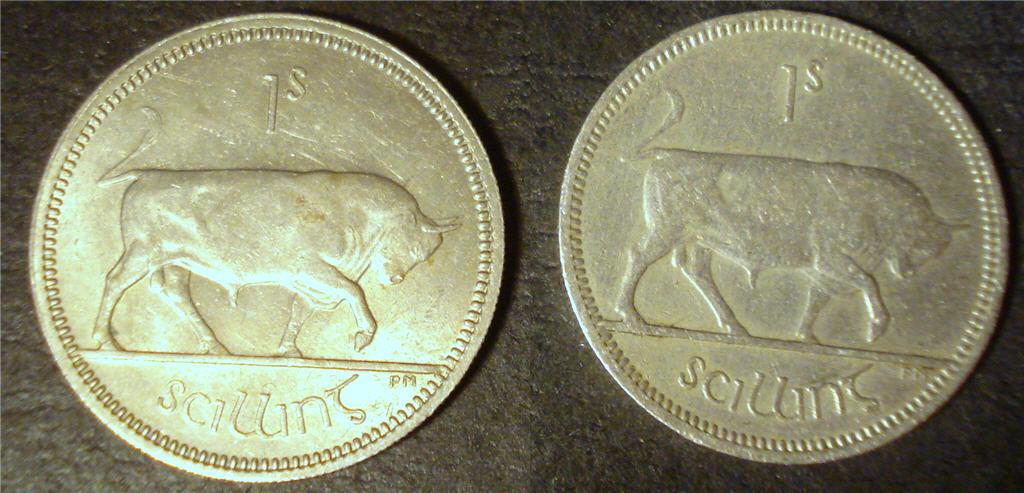<image>
Write a terse but informative summary of the picture. two silver coins with a bull reading 1S Scillint 